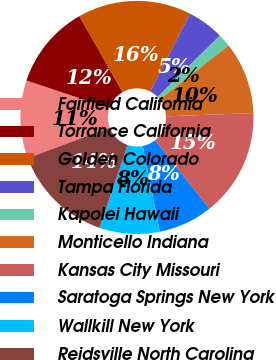Convert chart. <chart><loc_0><loc_0><loc_500><loc_500><pie_chart><fcel>Fairfield California<fcel>Torrance California<fcel>Golden Colorado<fcel>Tampa Florida<fcel>Kapolei Hawaii<fcel>Monticello Indiana<fcel>Kansas City Missouri<fcel>Saratoga Springs New York<fcel>Wallkill New York<fcel>Reidsville North Carolina<nl><fcel>10.82%<fcel>11.64%<fcel>15.74%<fcel>5.08%<fcel>1.8%<fcel>10.0%<fcel>14.92%<fcel>7.54%<fcel>8.36%<fcel>14.1%<nl></chart> 